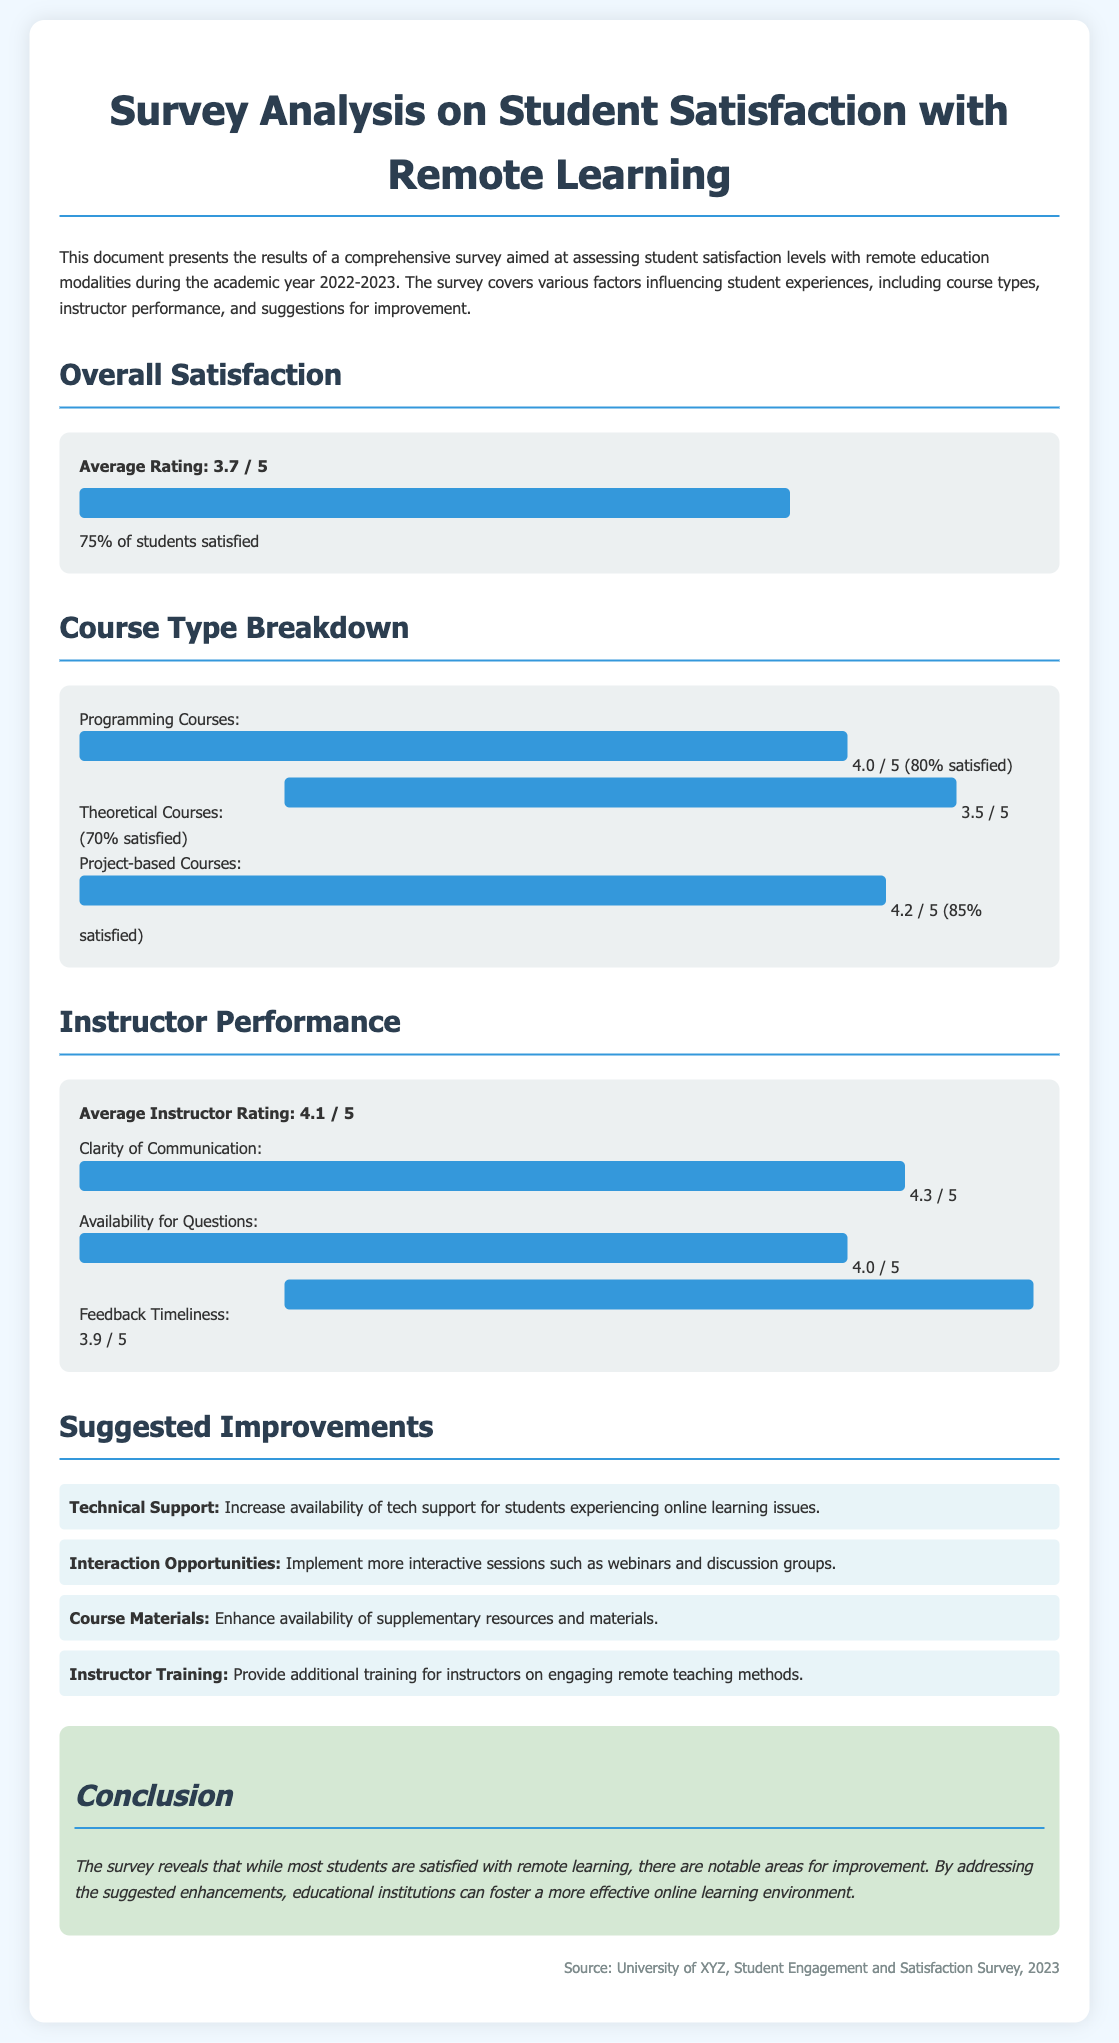What is the average rating for overall student satisfaction? The average rating for overall student satisfaction is given as 3.7 out of 5.
Answer: 3.7 / 5 What percentage of students are satisfied with remote learning? The document states that 75% of students are satisfied.
Answer: 75% What is the rating for Project-based Courses? The rating for Project-based Courses is 4.2 out of 5.
Answer: 4.2 / 5 What are the suggested improvements related to technical support? The document suggests increasing the availability of tech support for students.
Answer: Increase availability of tech support What is the average instructor rating mentioned in the document? The average instructor rating is indicated as 4.1 out of 5.
Answer: 4.1 / 5 How satisfied are students with Clarity of Communication from instructors? The rating for Clarity of Communication is 4.3 out of 5.
Answer: 4.3 / 5 Which course type has the highest satisfaction level? Project-based Courses have the highest satisfaction level.
Answer: Project-based Courses What is the rating for Theoretical Courses? The rating for Theoretical Courses is 3.5 out of 5.
Answer: 3.5 / 5 What improvement is suggested regarding instructor training? The document suggests providing additional training for instructors on engaging remote teaching methods.
Answer: Provide additional training for instructors 